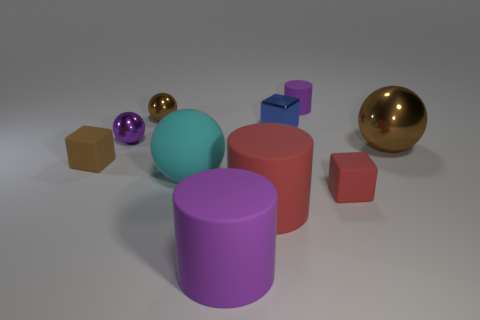Subtract all small matte cubes. How many cubes are left? 1 Subtract all yellow cylinders. How many brown balls are left? 2 Subtract all cyan balls. How many balls are left? 3 Subtract 0 yellow cylinders. How many objects are left? 10 Subtract all spheres. How many objects are left? 6 Subtract 2 balls. How many balls are left? 2 Subtract all brown balls. Subtract all brown cylinders. How many balls are left? 2 Subtract all brown shiny spheres. Subtract all brown rubber objects. How many objects are left? 7 Add 6 rubber cylinders. How many rubber cylinders are left? 9 Add 6 brown rubber objects. How many brown rubber objects exist? 7 